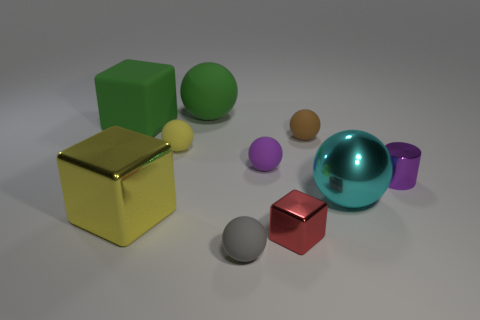There is a green object that is the same size as the green ball; what is its material?
Provide a succinct answer. Rubber. How many rubber objects are either brown objects or small yellow things?
Give a very brief answer. 2. There is a metallic object that is left of the purple metallic object and behind the yellow metal thing; what is its color?
Make the answer very short. Cyan. There is a large yellow metallic thing; how many purple cylinders are in front of it?
Offer a terse response. 0. What is the green cube made of?
Offer a terse response. Rubber. The tiny rubber ball that is in front of the big cube that is on the right side of the big green thing in front of the big green sphere is what color?
Provide a succinct answer. Gray. What number of green matte cylinders have the same size as the cyan metallic thing?
Give a very brief answer. 0. The rubber block that is left of the big matte sphere is what color?
Give a very brief answer. Green. How many other things are there of the same size as the yellow metallic cube?
Give a very brief answer. 3. What is the size of the object that is both in front of the large yellow metallic object and behind the gray rubber object?
Provide a succinct answer. Small. 